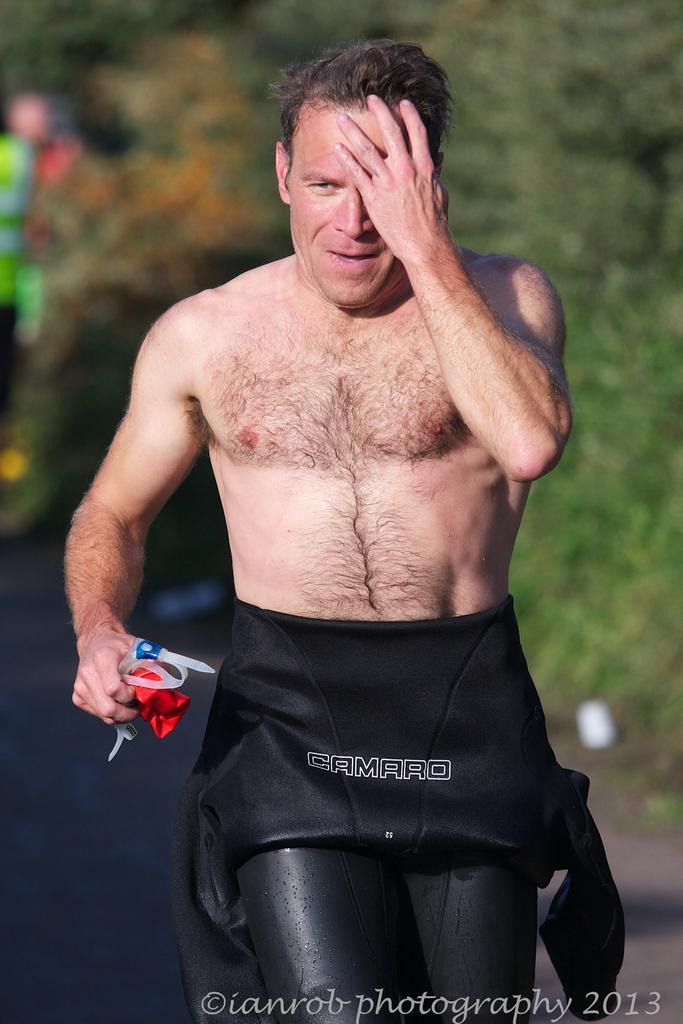Describe this image in one or two sentences. This picture is clicked outside. In the foreground we can see a man holding some objects and seems to be running on the ground. In the background we can see the green leaves and a person like thing and some other items. At the bottom we can see the watermark on the image. 